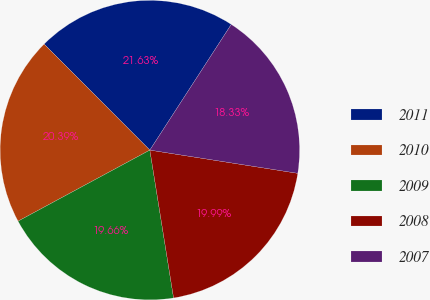<chart> <loc_0><loc_0><loc_500><loc_500><pie_chart><fcel>2011<fcel>2010<fcel>2009<fcel>2008<fcel>2007<nl><fcel>21.63%<fcel>20.39%<fcel>19.66%<fcel>19.99%<fcel>18.33%<nl></chart> 